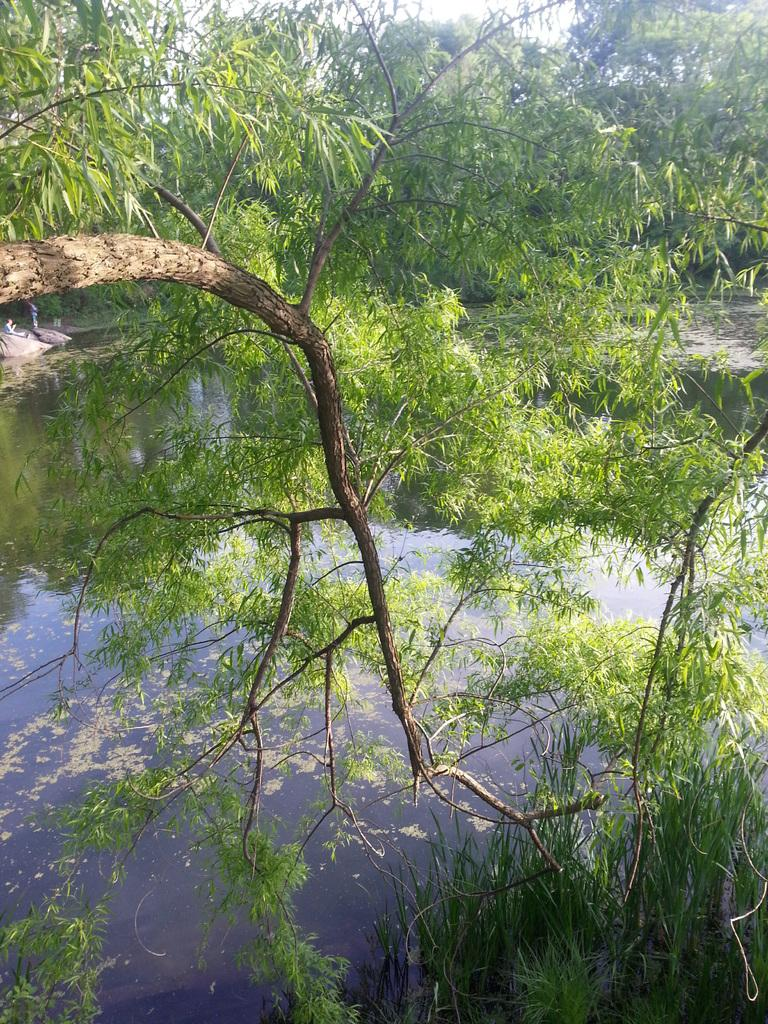What is visible in the image? Water and trees are visible in the image. Can you describe the water in the image? The image only shows water, without any specific details about it. What type of vegetation is present in the image? Trees are present in the image. Where is the club located in the image? There is no club present in the image. What type of tray is visible in the image? There is no tray present in the image. 